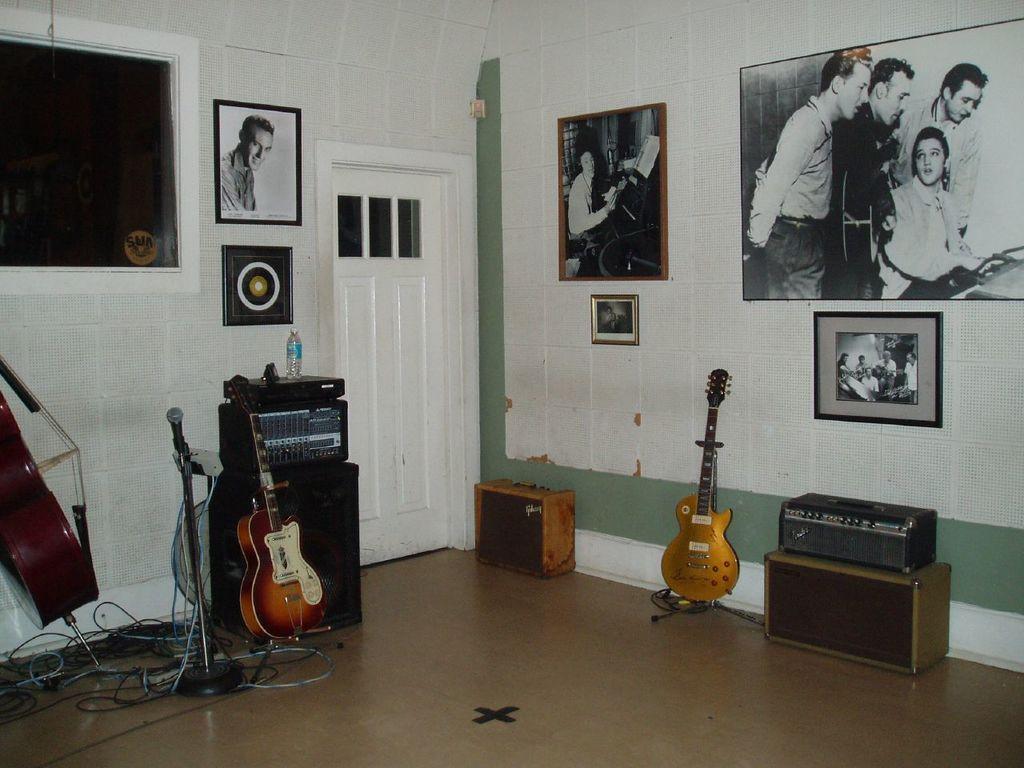In one or two sentences, can you explain what this image depicts? Here we can see a room full of musical instruments such as guitar and microphones present and there are photo frames present on the walls and there is a door present in the middle 